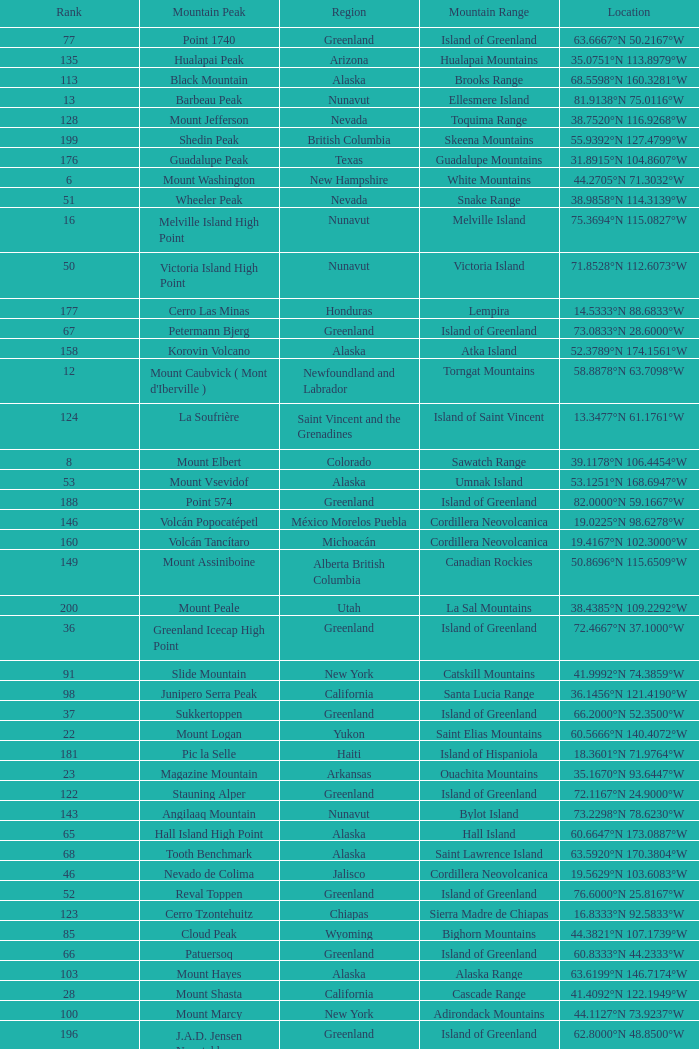Which Mountain Range has a Region of haiti, and a Location of 18.3601°n 71.9764°w? Island of Hispaniola. 